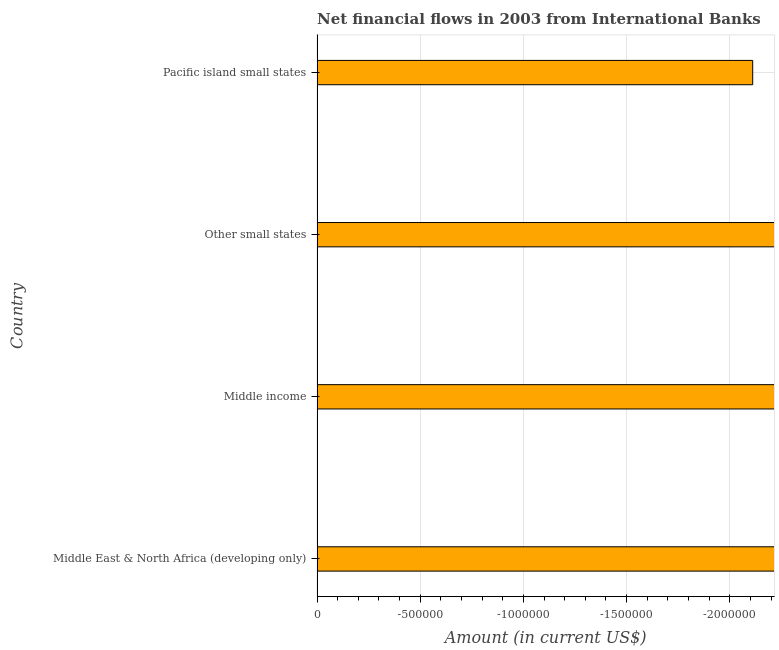Does the graph contain any zero values?
Provide a short and direct response. Yes. What is the title of the graph?
Provide a succinct answer. Net financial flows in 2003 from International Banks. What is the label or title of the Y-axis?
Ensure brevity in your answer.  Country. What is the net financial flows from ibrd in Other small states?
Offer a terse response. 0. What is the sum of the net financial flows from ibrd?
Your answer should be very brief. 0. What is the average net financial flows from ibrd per country?
Make the answer very short. 0. In how many countries, is the net financial flows from ibrd greater than the average net financial flows from ibrd taken over all countries?
Your response must be concise. 0. How many countries are there in the graph?
Provide a succinct answer. 4. What is the Amount (in current US$) in Middle East & North Africa (developing only)?
Provide a short and direct response. 0. 